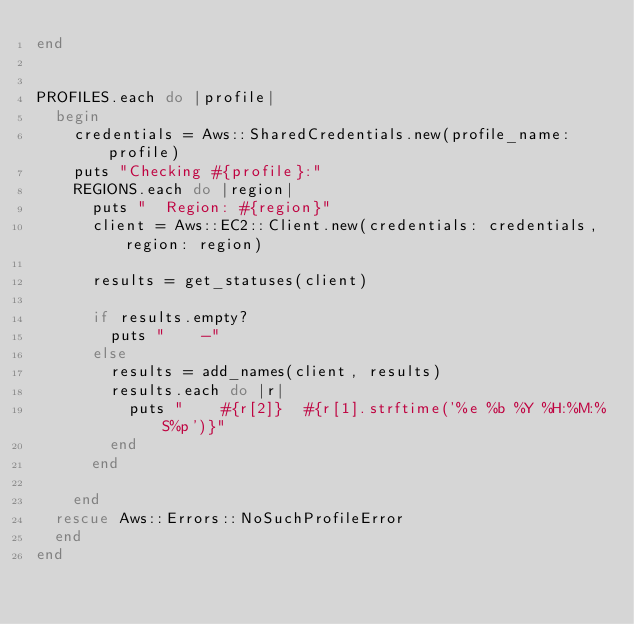Convert code to text. <code><loc_0><loc_0><loc_500><loc_500><_Ruby_>end


PROFILES.each do |profile|
  begin
    credentials = Aws::SharedCredentials.new(profile_name: profile)
    puts "Checking #{profile}:"
    REGIONS.each do |region|
      puts "  Region: #{region}"
      client = Aws::EC2::Client.new(credentials: credentials, region: region)

      results = get_statuses(client)

      if results.empty?
        puts "    -"
      else
        results = add_names(client, results)
        results.each do |r|
          puts "    #{r[2]}  #{r[1].strftime('%e %b %Y %H:%M:%S%p')}"
        end
      end

    end
  rescue Aws::Errors::NoSuchProfileError
  end
end
</code> 